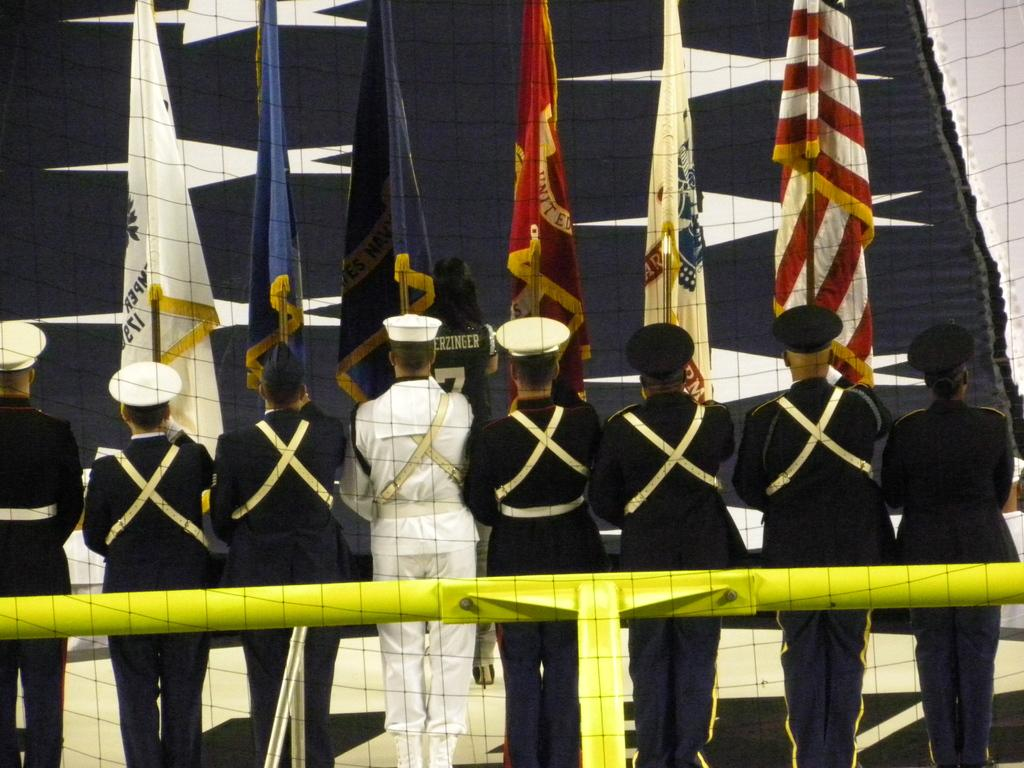How many people are in the image? There are people in the image, but the exact number is not specified. What are the people doing in the image? The people are standing and holding flags. What is behind the people in the image? There is a rod behind the people in the image. What can be seen in the background of the image? There is an object that looks like a flag in the background of the image. What type of advice is the person giving to the plane in the image? There is no plane present in the image, so it is not possible to answer that question. 